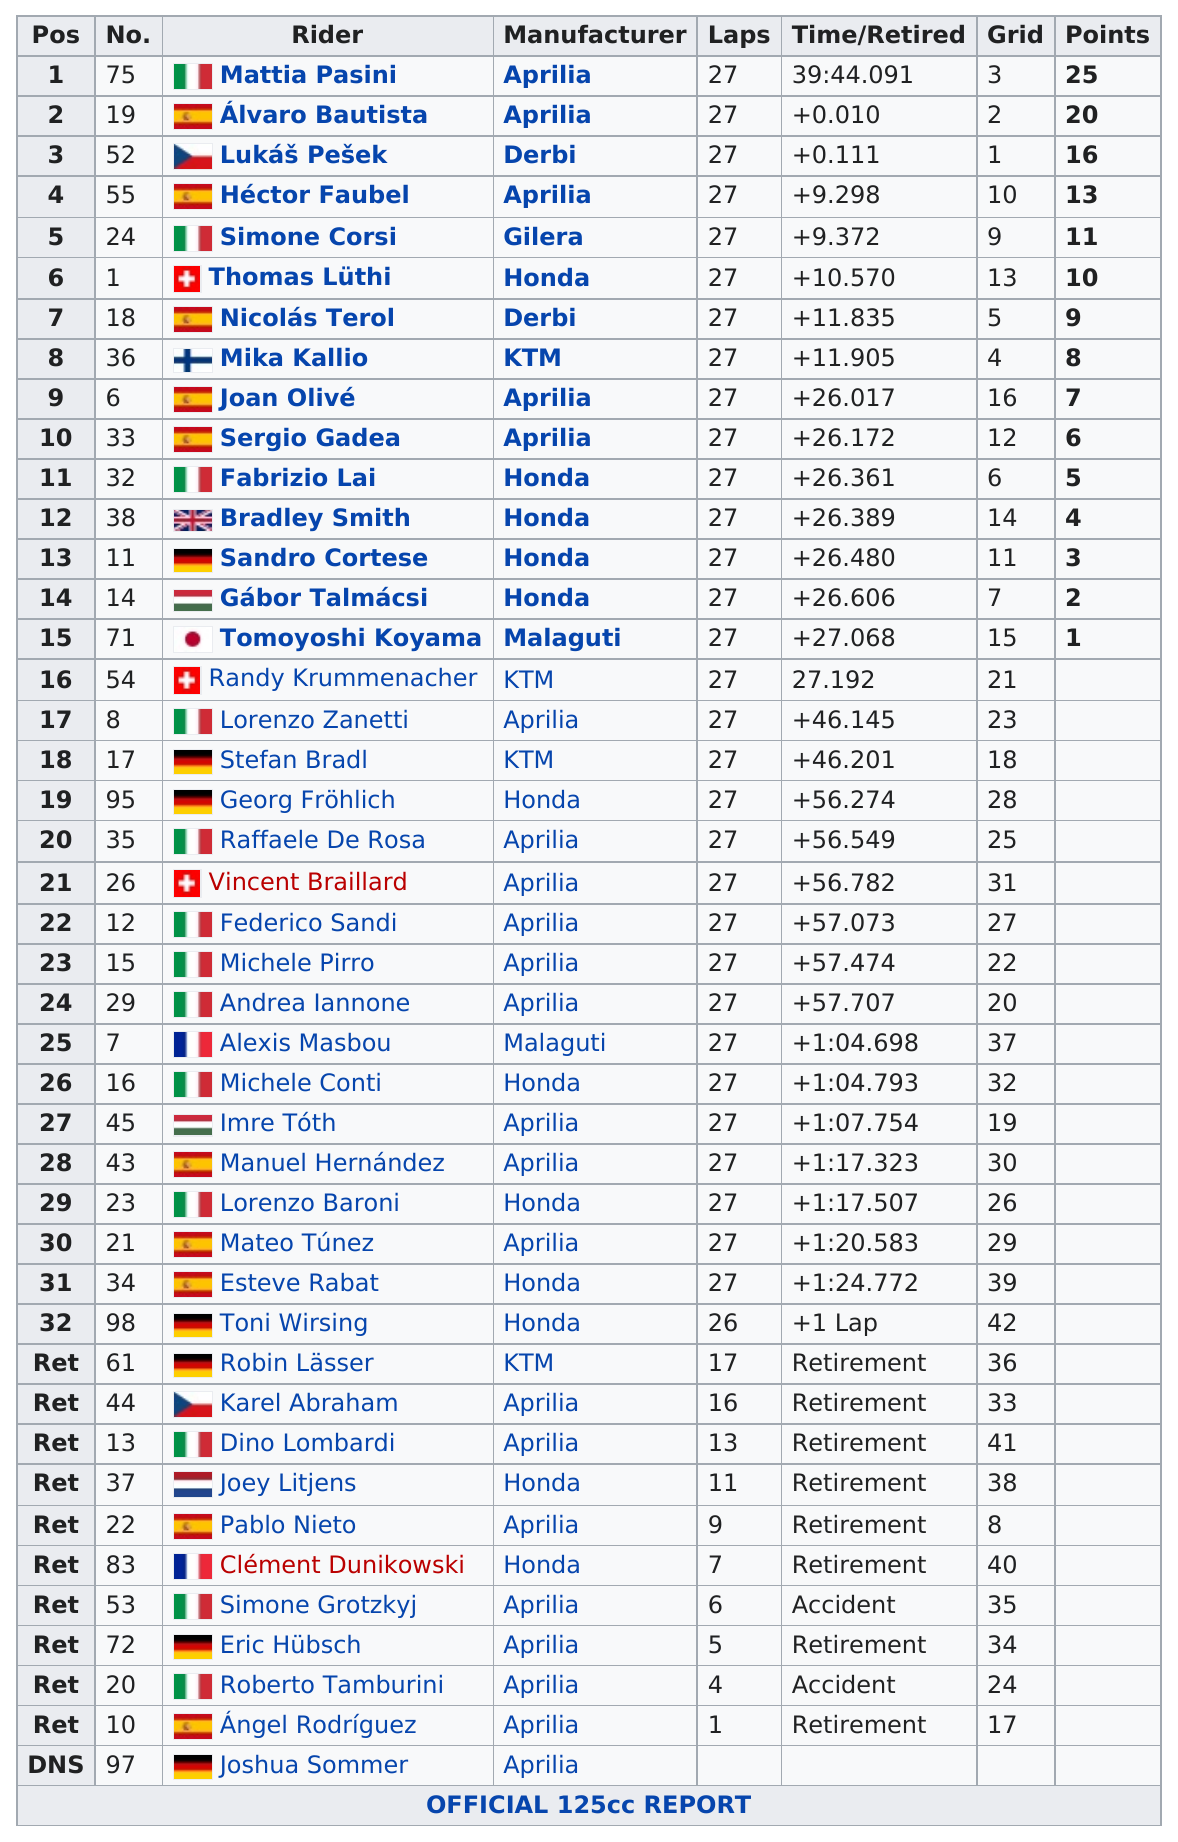Outline some significant characteristics in this image. The rider who earned the lowest amount of points among those in the top 15 positions is Tomoyoshi Koyama. Mattia Pasini, a racer, achieved at least 20 points. The average score of the top five riders is 17. Mattia Pasini was the rider who came in first with 25 points. Sergio Gadea placed higher than Bradl. 